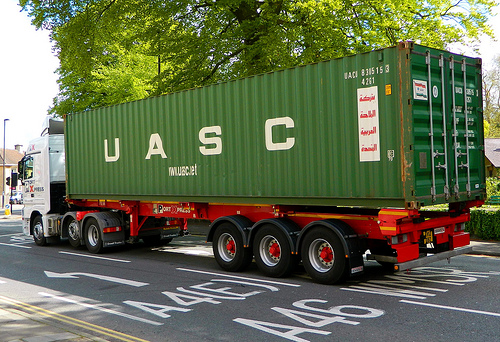What do both the truck and the container have in common? Both the truck and the container share the sharegpt4v/same green color. 